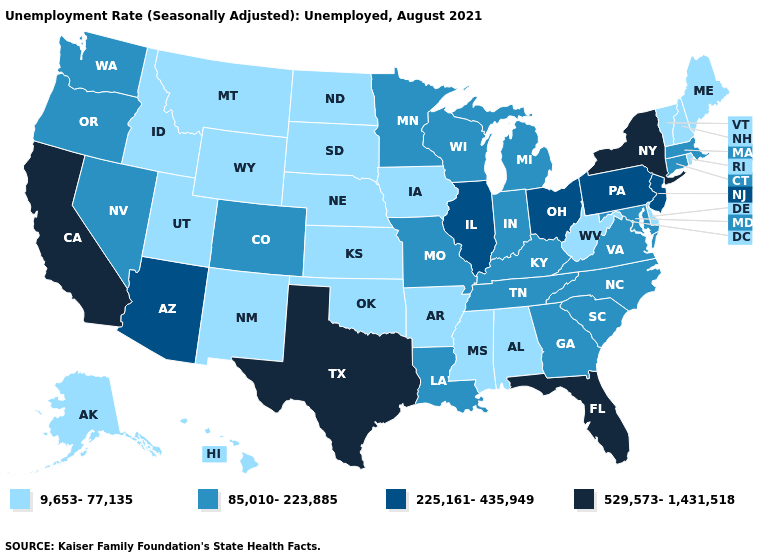Does Connecticut have the highest value in the USA?
Answer briefly. No. Name the states that have a value in the range 225,161-435,949?
Keep it brief. Arizona, Illinois, New Jersey, Ohio, Pennsylvania. Which states hav the highest value in the South?
Concise answer only. Florida, Texas. What is the lowest value in states that border Rhode Island?
Concise answer only. 85,010-223,885. Which states have the lowest value in the West?
Quick response, please. Alaska, Hawaii, Idaho, Montana, New Mexico, Utah, Wyoming. Does Virginia have a lower value than Connecticut?
Answer briefly. No. Name the states that have a value in the range 225,161-435,949?
Be succinct. Arizona, Illinois, New Jersey, Ohio, Pennsylvania. What is the lowest value in states that border Texas?
Answer briefly. 9,653-77,135. Name the states that have a value in the range 9,653-77,135?
Be succinct. Alabama, Alaska, Arkansas, Delaware, Hawaii, Idaho, Iowa, Kansas, Maine, Mississippi, Montana, Nebraska, New Hampshire, New Mexico, North Dakota, Oklahoma, Rhode Island, South Dakota, Utah, Vermont, West Virginia, Wyoming. What is the lowest value in the South?
Be succinct. 9,653-77,135. What is the value of Alabama?
Write a very short answer. 9,653-77,135. Among the states that border Michigan , does Wisconsin have the highest value?
Answer briefly. No. Does Minnesota have the highest value in the USA?
Answer briefly. No. What is the value of South Carolina?
Keep it brief. 85,010-223,885. Does Michigan have a higher value than Minnesota?
Give a very brief answer. No. 